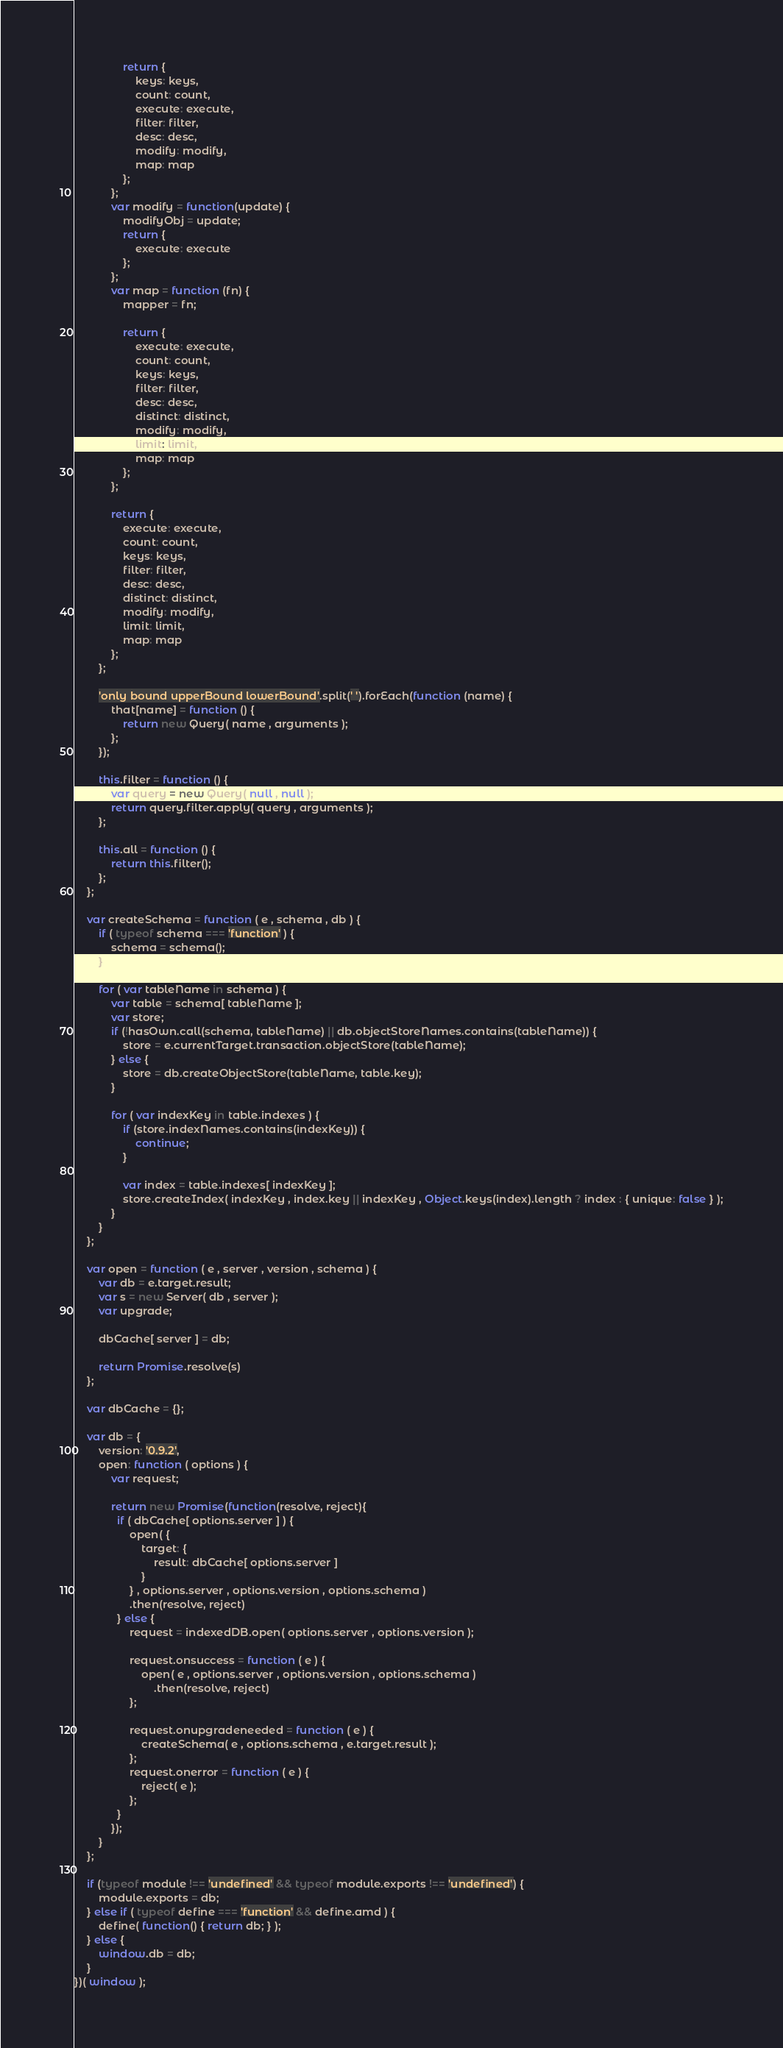<code> <loc_0><loc_0><loc_500><loc_500><_JavaScript_>                return {
                    keys: keys,
                    count: count,
                    execute: execute,
                    filter: filter,
                    desc: desc,
                    modify: modify,
                    map: map
                };
            };
            var modify = function(update) {
                modifyObj = update;
                return {
                    execute: execute
                };
            };
            var map = function (fn) {
                mapper = fn;

                return {
                    execute: execute,
                    count: count,
                    keys: keys,
                    filter: filter,
                    desc: desc,
                    distinct: distinct,
                    modify: modify,
                    limit: limit,
                    map: map
                };
            };

            return {
                execute: execute,
                count: count,
                keys: keys,
                filter: filter,
                desc: desc,
                distinct: distinct,
                modify: modify,
                limit: limit,
                map: map
            };
        };
        
        'only bound upperBound lowerBound'.split(' ').forEach(function (name) {
            that[name] = function () {
                return new Query( name , arguments );
            };
        });

        this.filter = function () {
            var query = new Query( null , null );
            return query.filter.apply( query , arguments );
        };

        this.all = function () {
            return this.filter();
        };
    };
    
    var createSchema = function ( e , schema , db ) {
        if ( typeof schema === 'function' ) {
            schema = schema();
        }
        
        for ( var tableName in schema ) {
            var table = schema[ tableName ];
            var store;
            if (!hasOwn.call(schema, tableName) || db.objectStoreNames.contains(tableName)) {
                store = e.currentTarget.transaction.objectStore(tableName);
            } else {
                store = db.createObjectStore(tableName, table.key);
            }

            for ( var indexKey in table.indexes ) {
                if (store.indexNames.contains(indexKey)) {
                    continue;
                }
                
                var index = table.indexes[ indexKey ];
                store.createIndex( indexKey , index.key || indexKey , Object.keys(index).length ? index : { unique: false } );
            }
        }
    };
    
    var open = function ( e , server , version , schema ) {
        var db = e.target.result;
        var s = new Server( db , server );
        var upgrade;

        dbCache[ server ] = db;

        return Promise.resolve(s)
    };

    var dbCache = {};

    var db = {
        version: '0.9.2',
        open: function ( options ) {
            var request;

            return new Promise(function(resolve, reject){
              if ( dbCache[ options.server ] ) {
                  open( {
                      target: {
                          result: dbCache[ options.server ]
                      }
                  } , options.server , options.version , options.schema )
                  .then(resolve, reject)
              } else {
                  request = indexedDB.open( options.server , options.version );
                              
                  request.onsuccess = function ( e ) {
                      open( e , options.server , options.version , options.schema )
                          .then(resolve, reject)
                  };
              
                  request.onupgradeneeded = function ( e ) {
                      createSchema( e , options.schema , e.target.result );
                  };
                  request.onerror = function ( e ) {
                      reject( e );
                  };
              }
            });
        }
    };

    if (typeof module !== 'undefined' && typeof module.exports !== 'undefined') {
        module.exports = db;
    } else if ( typeof define === 'function' && define.amd ) {
        define( function() { return db; } );
    } else {
        window.db = db;
    }
})( window );
</code> 